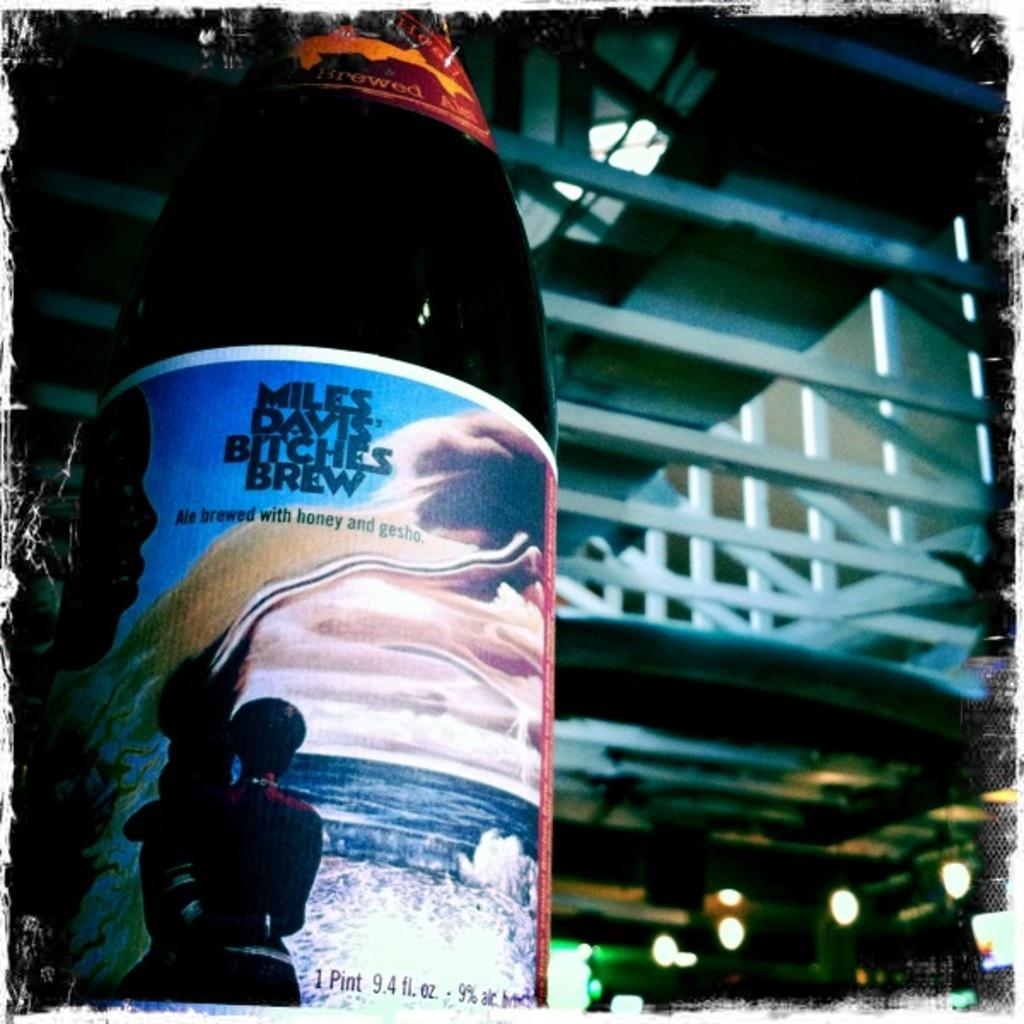<image>
Create a compact narrative representing the image presented. A  1 pint bottle of Miles Davis Bitches Brew made with honey and gesho. 